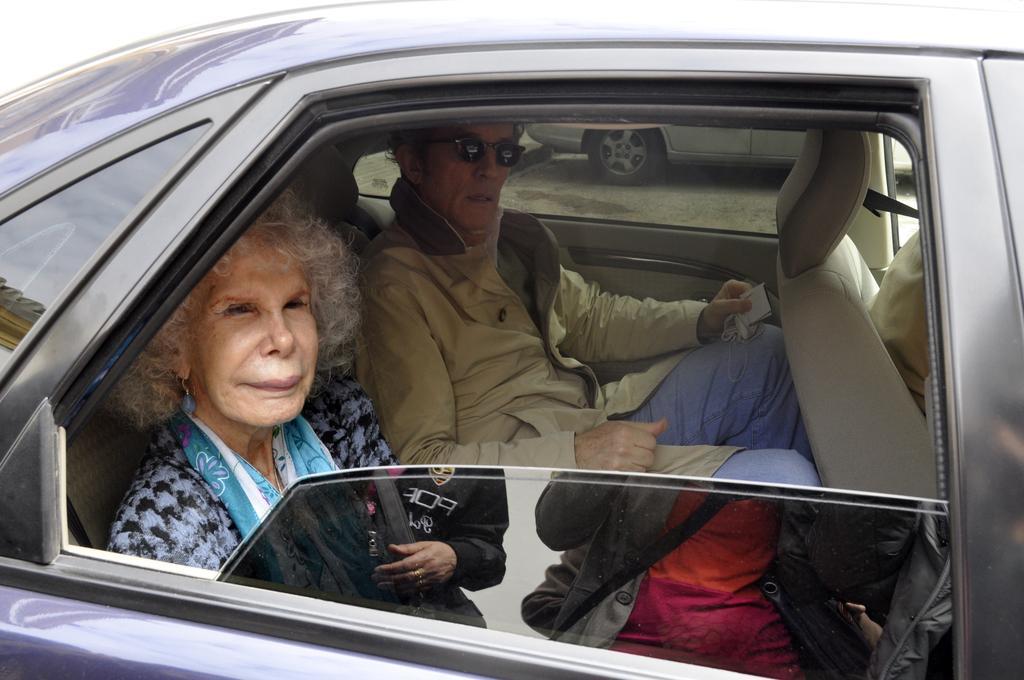In one or two sentences, can you explain what this image depicts? In this image I can see a car which is in black colour and in the car we have two persons sitting in the car, one is woman and other person is a man. 